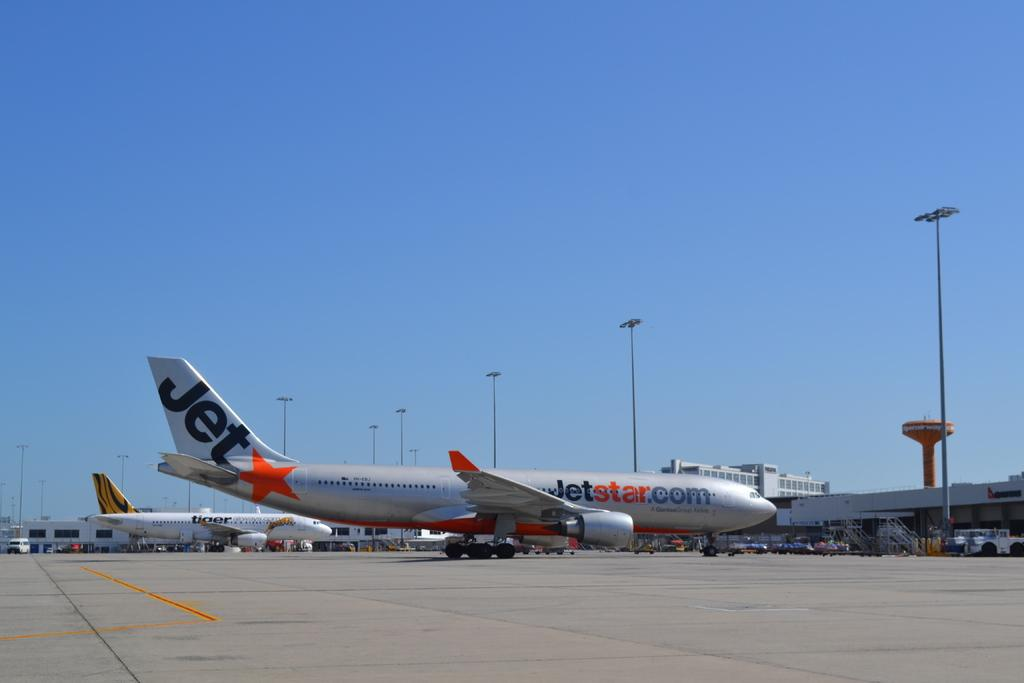<image>
Present a compact description of the photo's key features. the jetstar.com plane is sitting at the airport 